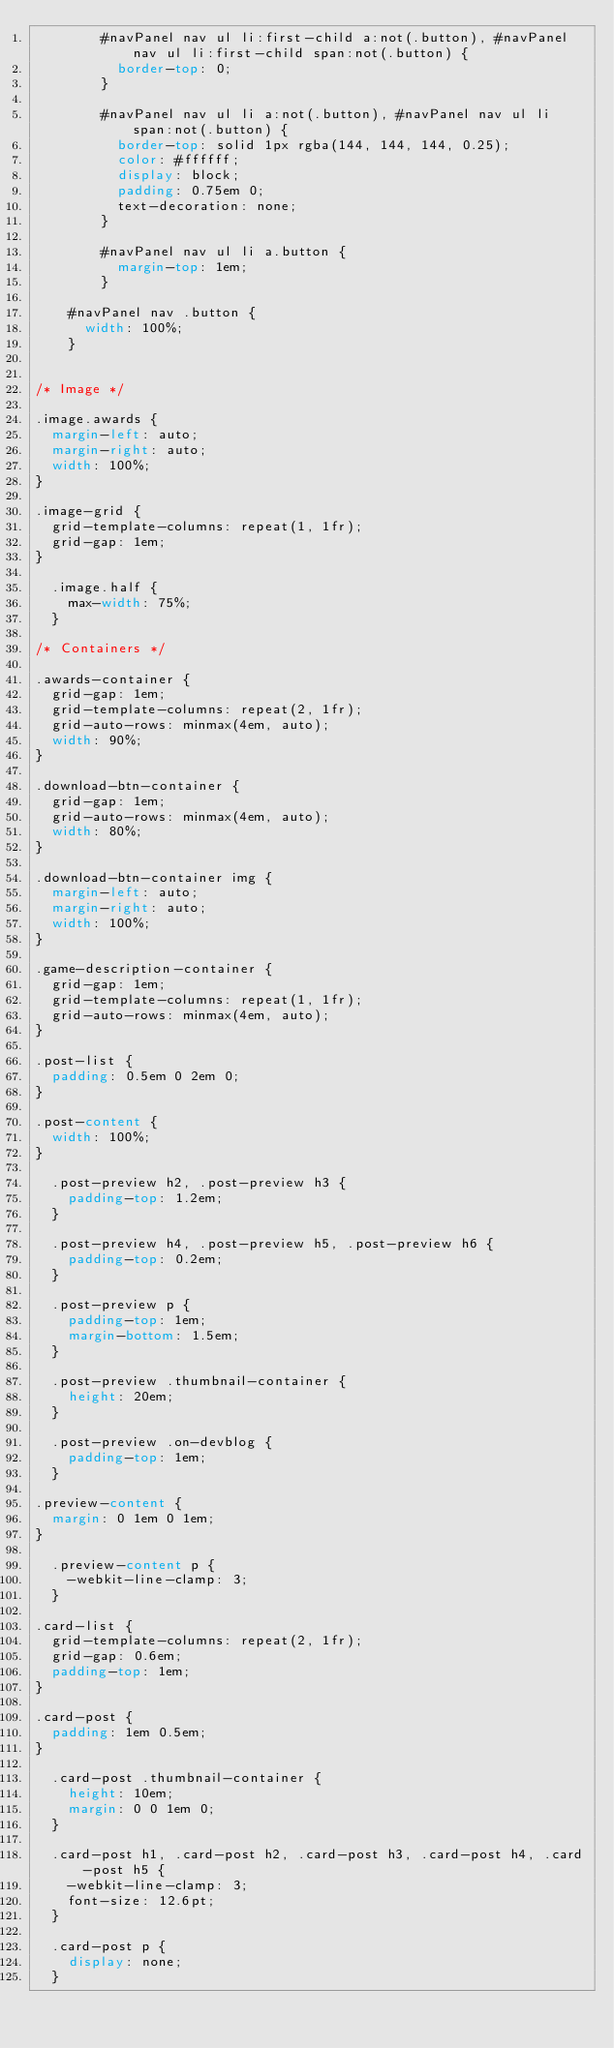<code> <loc_0><loc_0><loc_500><loc_500><_CSS_>				#navPanel nav ul li:first-child a:not(.button), #navPanel nav ul li:first-child span:not(.button) {
					border-top: 0;
				}

				#navPanel nav ul li a:not(.button), #navPanel nav ul li span:not(.button) {
					border-top: solid 1px rgba(144, 144, 144, 0.25);
					color: #ffffff;
					display: block;
					padding: 0.75em 0;
					text-decoration: none;
				}

				#navPanel nav ul li a.button {
					margin-top: 1em;
				}

		#navPanel nav .button {
			width: 100%;
		}


/* Image */

.image.awards {
	margin-left: auto;
	margin-right: auto;
	width: 100%;
}

.image-grid {
	grid-template-columns: repeat(1, 1fr);
	grid-gap: 1em;
}

	.image.half {
		max-width: 75%;
	}

/* Containers */

.awards-container {			
	grid-gap: 1em;
	grid-template-columns: repeat(2, 1fr);
	grid-auto-rows: minmax(4em, auto);
	width: 90%;
}

.download-btn-container {			
	grid-gap: 1em;
	grid-auto-rows: minmax(4em, auto);
	width: 80%;
}

.download-btn-container img {
	margin-left: auto;
	margin-right: auto;
	width: 100%;
}

.game-description-container {			
	grid-gap: 1em;
	grid-template-columns: repeat(1, 1fr);
	grid-auto-rows: minmax(4em, auto);
}

.post-list {
	padding: 0.5em 0 2em 0;
}

.post-content {
	width: 100%;
}

	.post-preview h2, .post-preview h3 {
		padding-top: 1.2em;
	}

	.post-preview h4, .post-preview h5, .post-preview h6 {
		padding-top: 0.2em;
	}

	.post-preview p {
		padding-top: 1em;
		margin-bottom: 1.5em;
	}

	.post-preview .thumbnail-container {
		height: 20em;
	}

	.post-preview .on-devblog {
		padding-top: 1em;
	}

.preview-content {
	margin: 0 1em 0 1em;
}

	.preview-content p {
		-webkit-line-clamp: 3;
	}

.card-list {
	grid-template-columns: repeat(2, 1fr);
	grid-gap: 0.6em;
	padding-top: 1em;
}

.card-post {
	padding: 1em 0.5em;
}

	.card-post .thumbnail-container {
		height: 10em;
		margin: 0 0 1em 0;
	}

	.card-post h1, .card-post h2, .card-post h3, .card-post h4, .card-post h5 {
		-webkit-line-clamp: 3;
		font-size: 12.6pt;
	}

	.card-post p {
		display: none;
	}</code> 